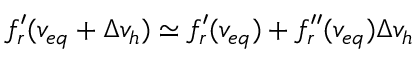<formula> <loc_0><loc_0><loc_500><loc_500>f _ { r } ^ { \prime } ( v _ { e q } + \Delta v _ { h } ) \simeq f _ { r } ^ { \prime } ( v _ { e q } ) + f _ { r } ^ { \prime \prime } ( v _ { e q } ) \Delta v _ { h }</formula> 